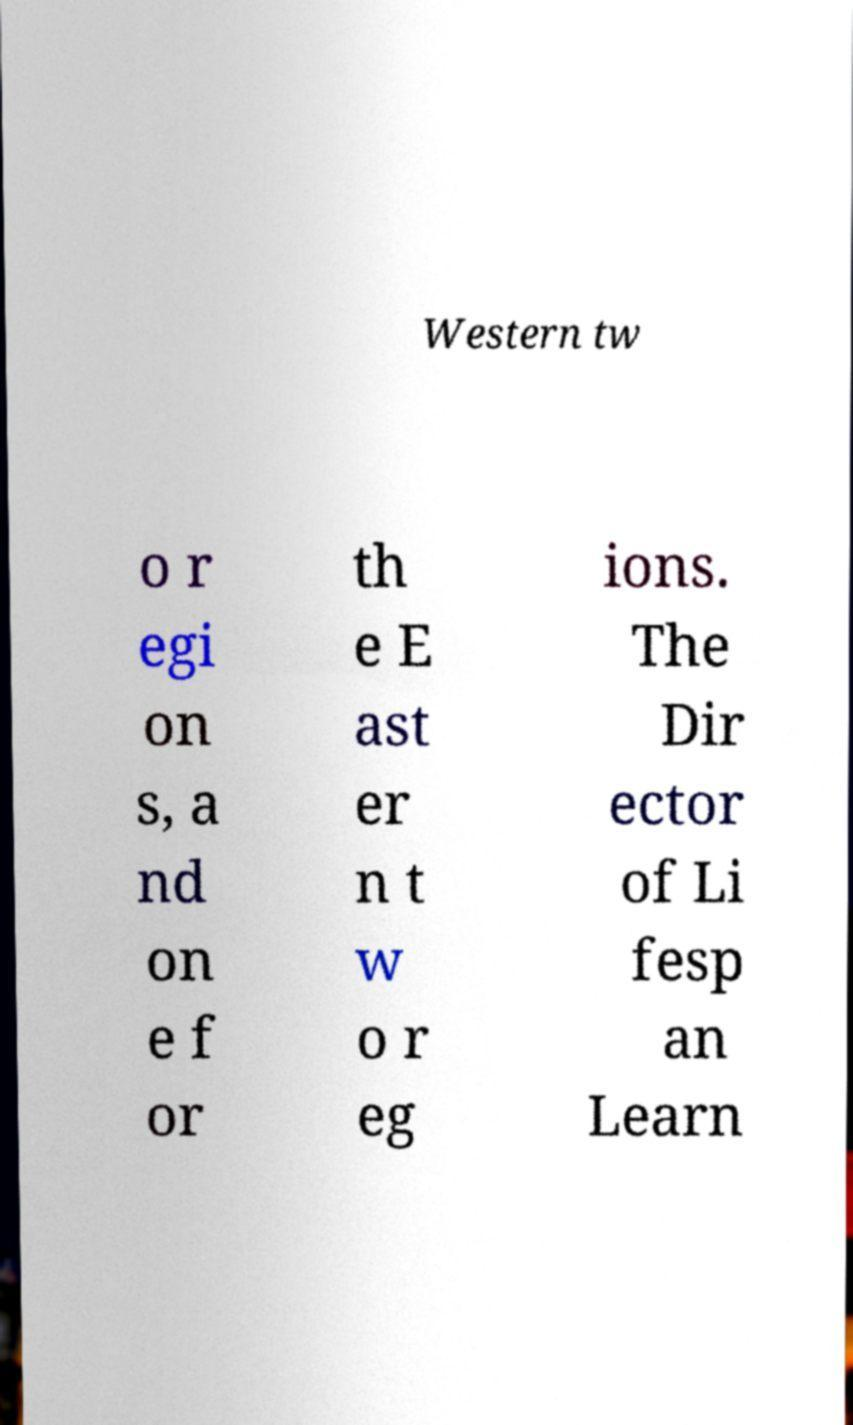Please read and relay the text visible in this image. What does it say? Western tw o r egi on s, a nd on e f or th e E ast er n t w o r eg ions. The Dir ector of Li fesp an Learn 